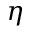<formula> <loc_0><loc_0><loc_500><loc_500>\eta</formula> 